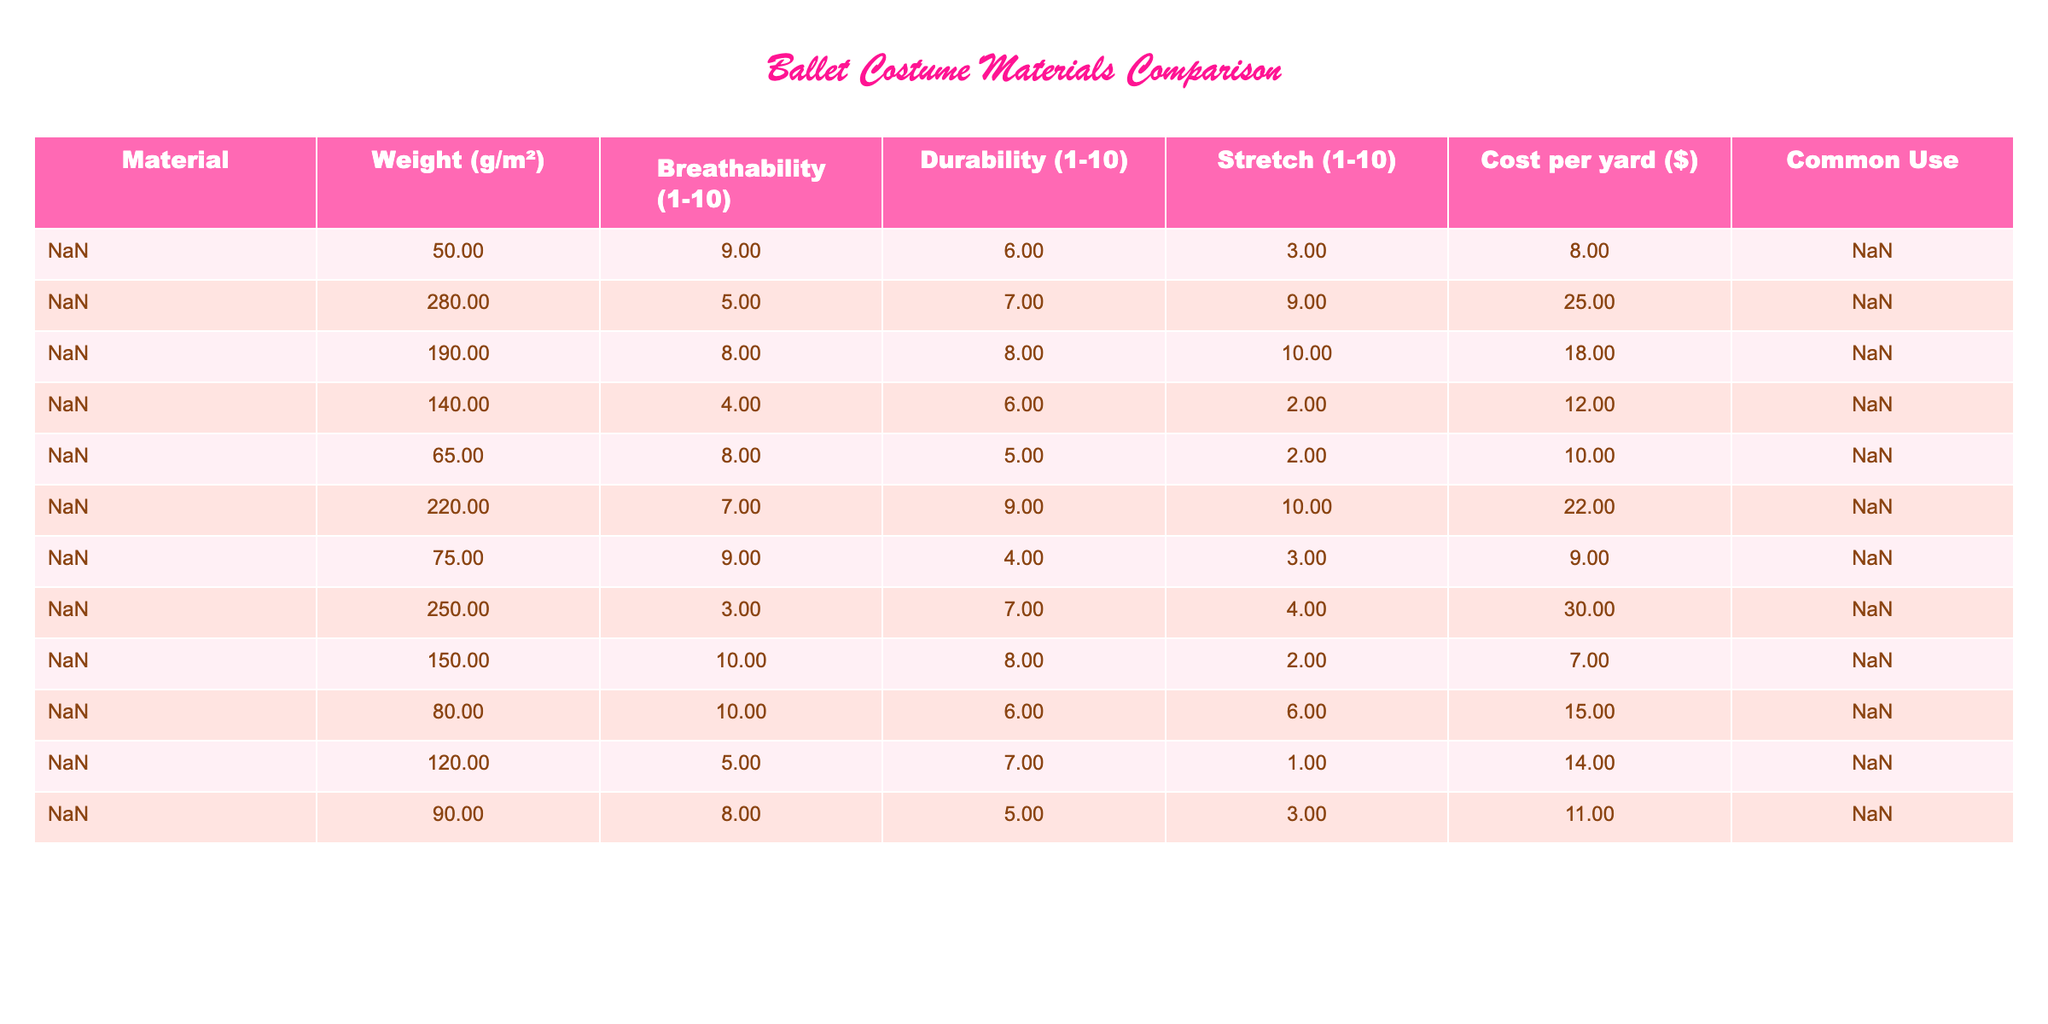What is the weight of Tulle in grams per square meter? The table shows that the weight of Tulle is listed as 50 g/m².
Answer: 50 g/m² Which material has the highest breathability rating? Looking at the breathability column, Tulle and Cotton both have a rating of 10. Since both are the highest scores, they tie for the highest breathability rating.
Answer: Tulle and Cotton What is the common use for Stretch Velvet? The table indicates that Stretch Velvet is commonly used for bodices and sleeves.
Answer: Bodices and sleeves Is Sequin Fabric more durable than Taffeta? By checking the durability ratings, Sequin Fabric has a rating of 7, while Taffeta has a rating of 7 as well. Therefore, they are equally durable.
Answer: Yes What is the average cost per yard of the materials listed? Adding the costs per yard (8 + 25 + 18 + 12 + 10 + 22 + 9 + 30 + 7 + 15 + 14 + 11 =  3.75) and dividing by 12 gives an average of $14.08.
Answer: $14.08 Which material has the lowest stretch rating, and what is that rating? In the table, Taffeta shows a stretch rating of 1, which is the lowest among all materials.
Answer: Taffeta, 1 If you wanted a costume that is both highly breathable and lightweight, which materials would you consider? Tulle (breathability 9, weight 50 g/m²) and Cotton (breathability 10, weight 150 g/m²) stand out for their high breathability and relatively low weight.
Answer: Tulle, Cotton How much heavier is Lycra than Tulle? Lycra weighs 220 g/m², while Tulle weighs 50 g/m². The difference is 220 - 50 = 170 g/m².
Answer: 170 g/m² Does any material have a breathability rating of 3? Sequin Fabric has a breathability rating of 3 according to the table.
Answer: Yes Which fabric has both a high stretch rating and moderate durability? From the table, Spandex has a stretch rating of 10 and a durability rating of 8, qualifying it for high stretch and moderate durability.
Answer: Spandex 